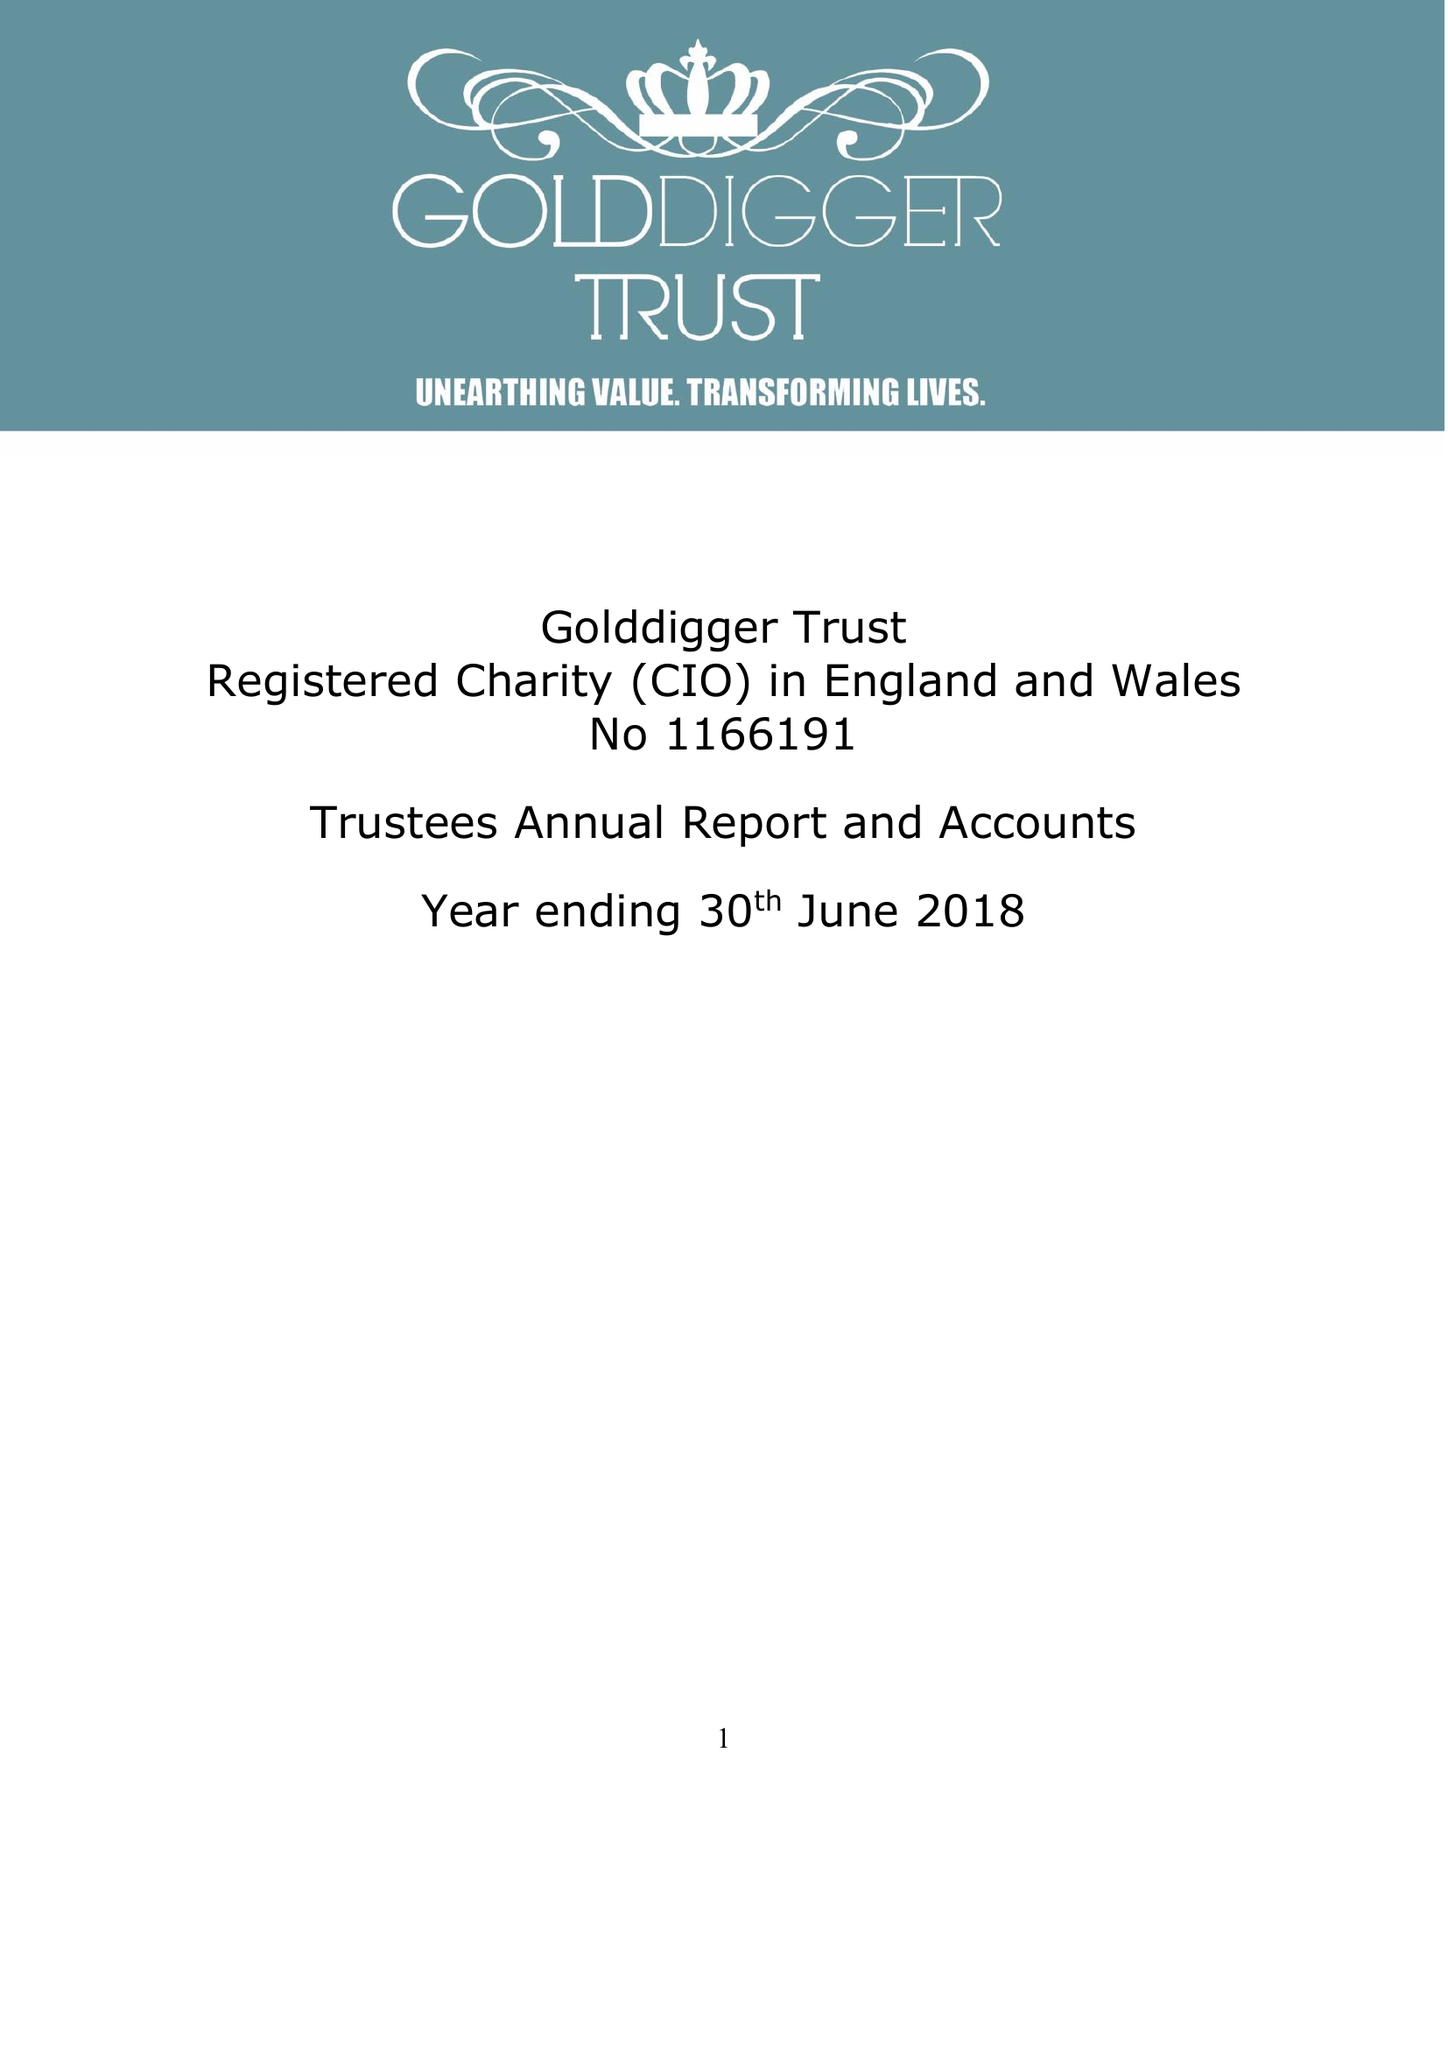What is the value for the charity_name?
Answer the question using a single word or phrase. Golddigger Trust 